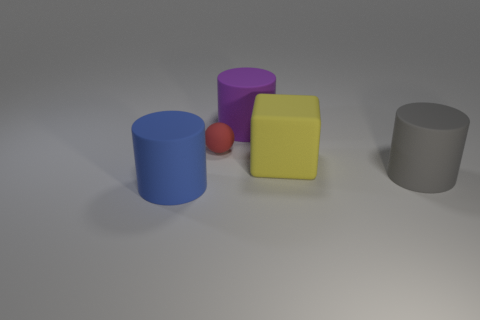Is there another large yellow ball made of the same material as the ball? Based on the visible elements in the image, there is no other large yellow ball present. The only ball depicted is red and significantly smaller than the yellow cube alongside it. 